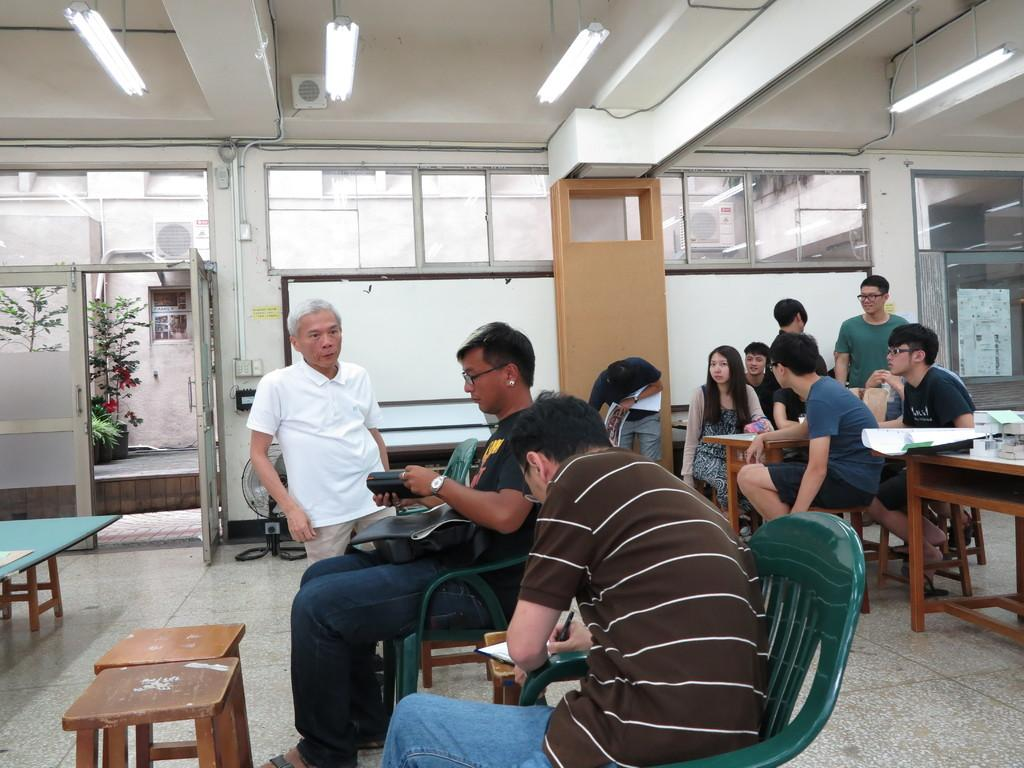What type of living organism can be seen in the image? There is a plant in the image. What is the background of the image made of? There is a wall in the image. What are the people in the image doing? There are people sitting on chairs in the image. What piece of furniture is present in the image? There is a table in the image. How many clocks are hanging on the wall in the image? There are no clocks visible in the image; only a wall and a plant are present. What type of thumb can be seen interacting with the plant in the image? There is no thumb present in the image; only a plant and a wall are visible. 